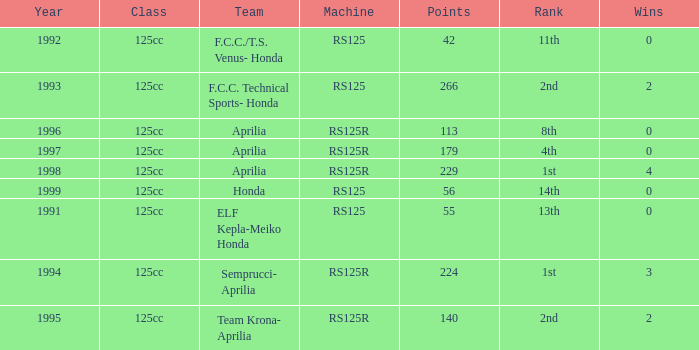Which team had a year over 1995, machine of RS125R, and ranked 1st? Aprilia. 